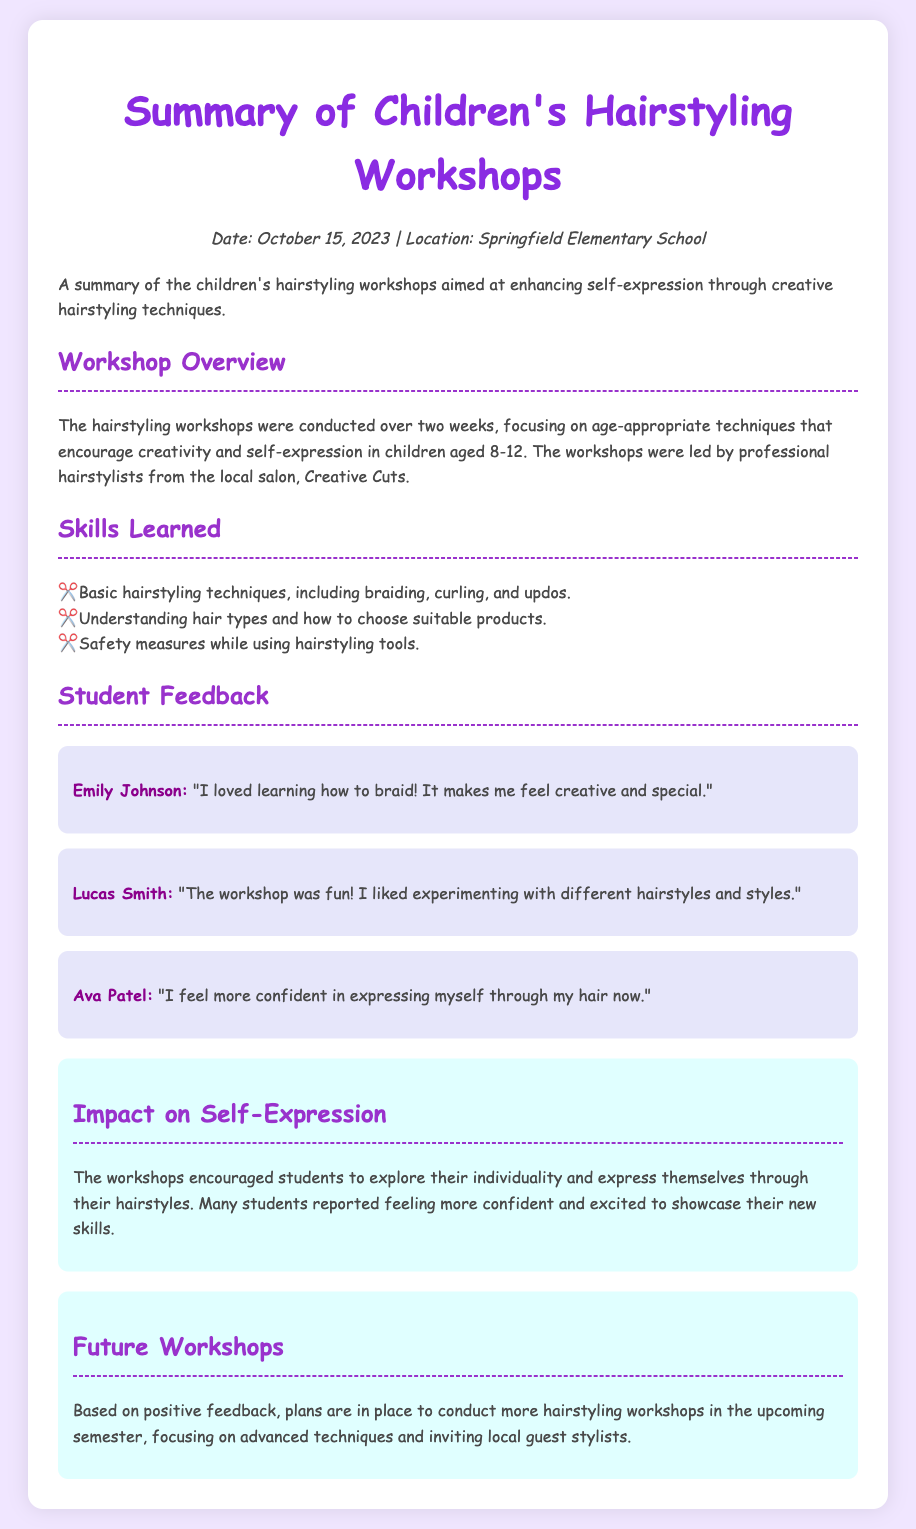What was the date of the workshops? The date of the workshops is mentioned in the document as October 15, 2023.
Answer: October 15, 2023 Where were the workshops held? The workshops took place at Springfield Elementary School, as stated in the document.
Answer: Springfield Elementary School How long were the workshops conducted? The document states that the workshops were conducted over two weeks.
Answer: Two weeks What age group participated in the workshops? The workshops focused on children aged 8-12, which is specified in the overview section.
Answer: 8-12 Which skills were taught during the workshops? The document lists skills such as basic hairstyling techniques, understanding hair types, and safety measures.
Answer: Braiding, curling, and updos What did Emily Johnson think of the workshop? Emily Johnson shared her positive experience about learning to braid, as quoted in the feedback section.
Answer: "I loved learning how to braid!" What impact did the workshops have on the students' self-expression? The impact section describes that students felt more confident and excited to showcase their new skills.
Answer: More confident What are the plans for future workshops? Future workshops will focus on advanced techniques and inviting local guest stylists, as mentioned in the document.
Answer: Advanced techniques and guest stylists 